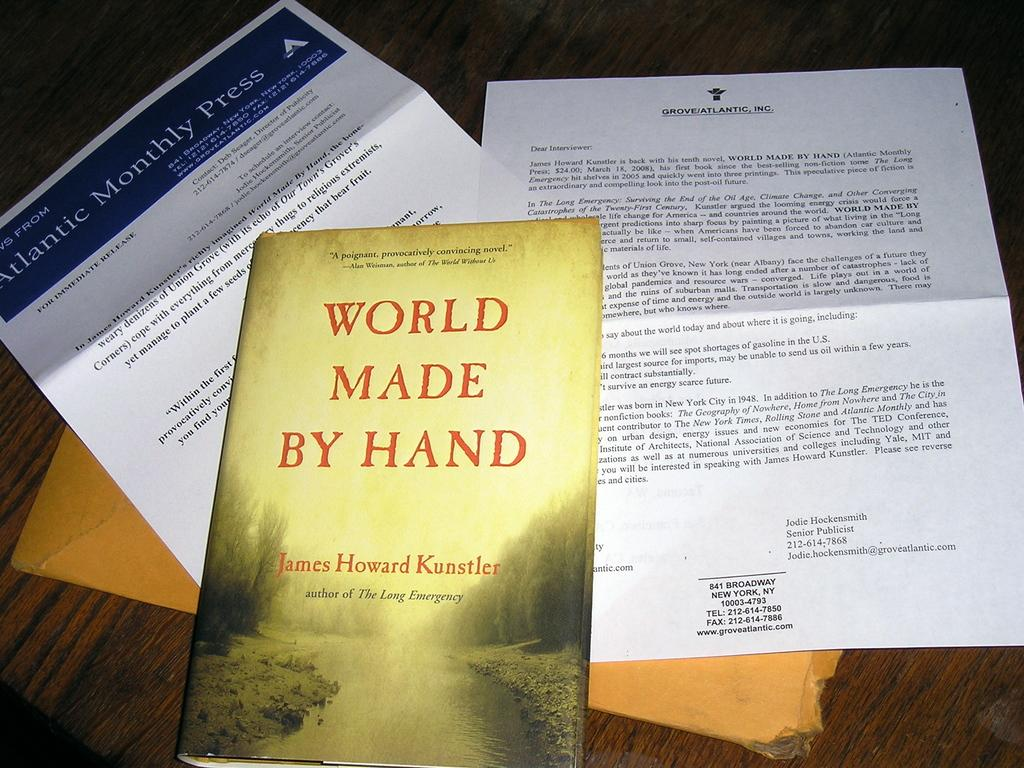What objects can be seen on the table in the image? There are papers, cardboard, and a book on the table in the image. Can you describe the type of materials present on the table? The materials present on the table include paper, cardboard, and the cover of the book. What might be the purpose of the items on the table? The items on the table may be related to reading, writing, or organizing information. Where might this image have been taken? The image may have been taken in a room, as there is a table and various objects present. What type of reaction can be seen in the image? There is no reaction visible in the image, as it only shows objects on a table. How does the cardboard provide support in the image? The cardboard does not provide support in the image; it is simply an object on the table. 